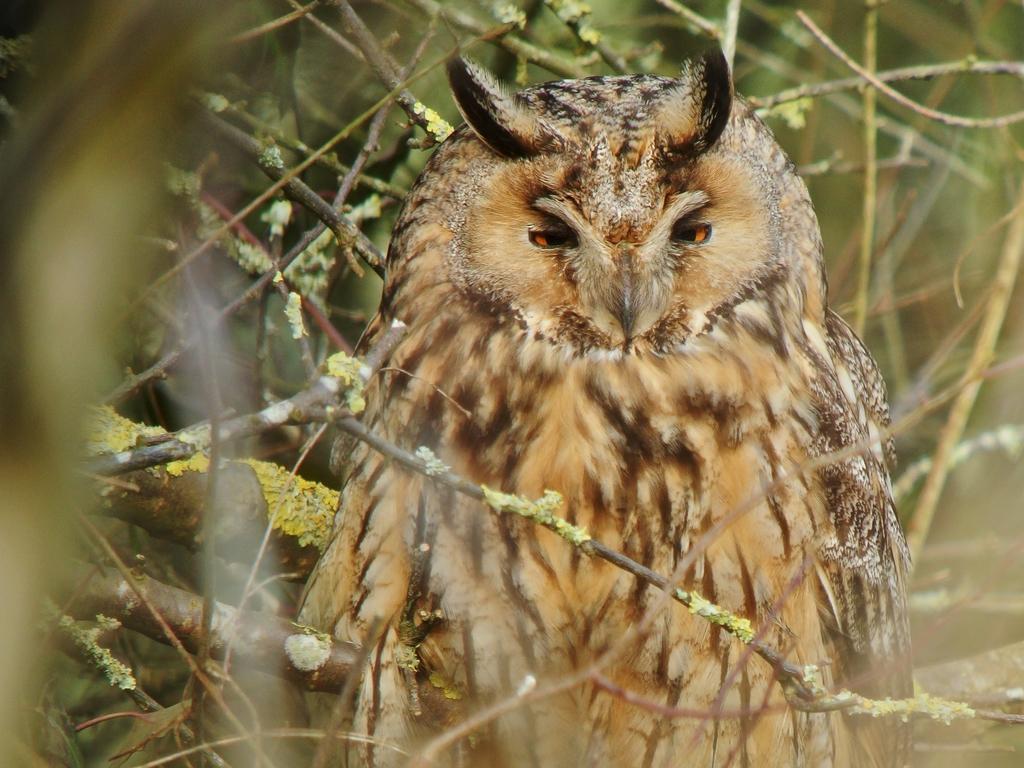Please provide a concise description of this image. In this image there is a bird. There are branches of the trees. 